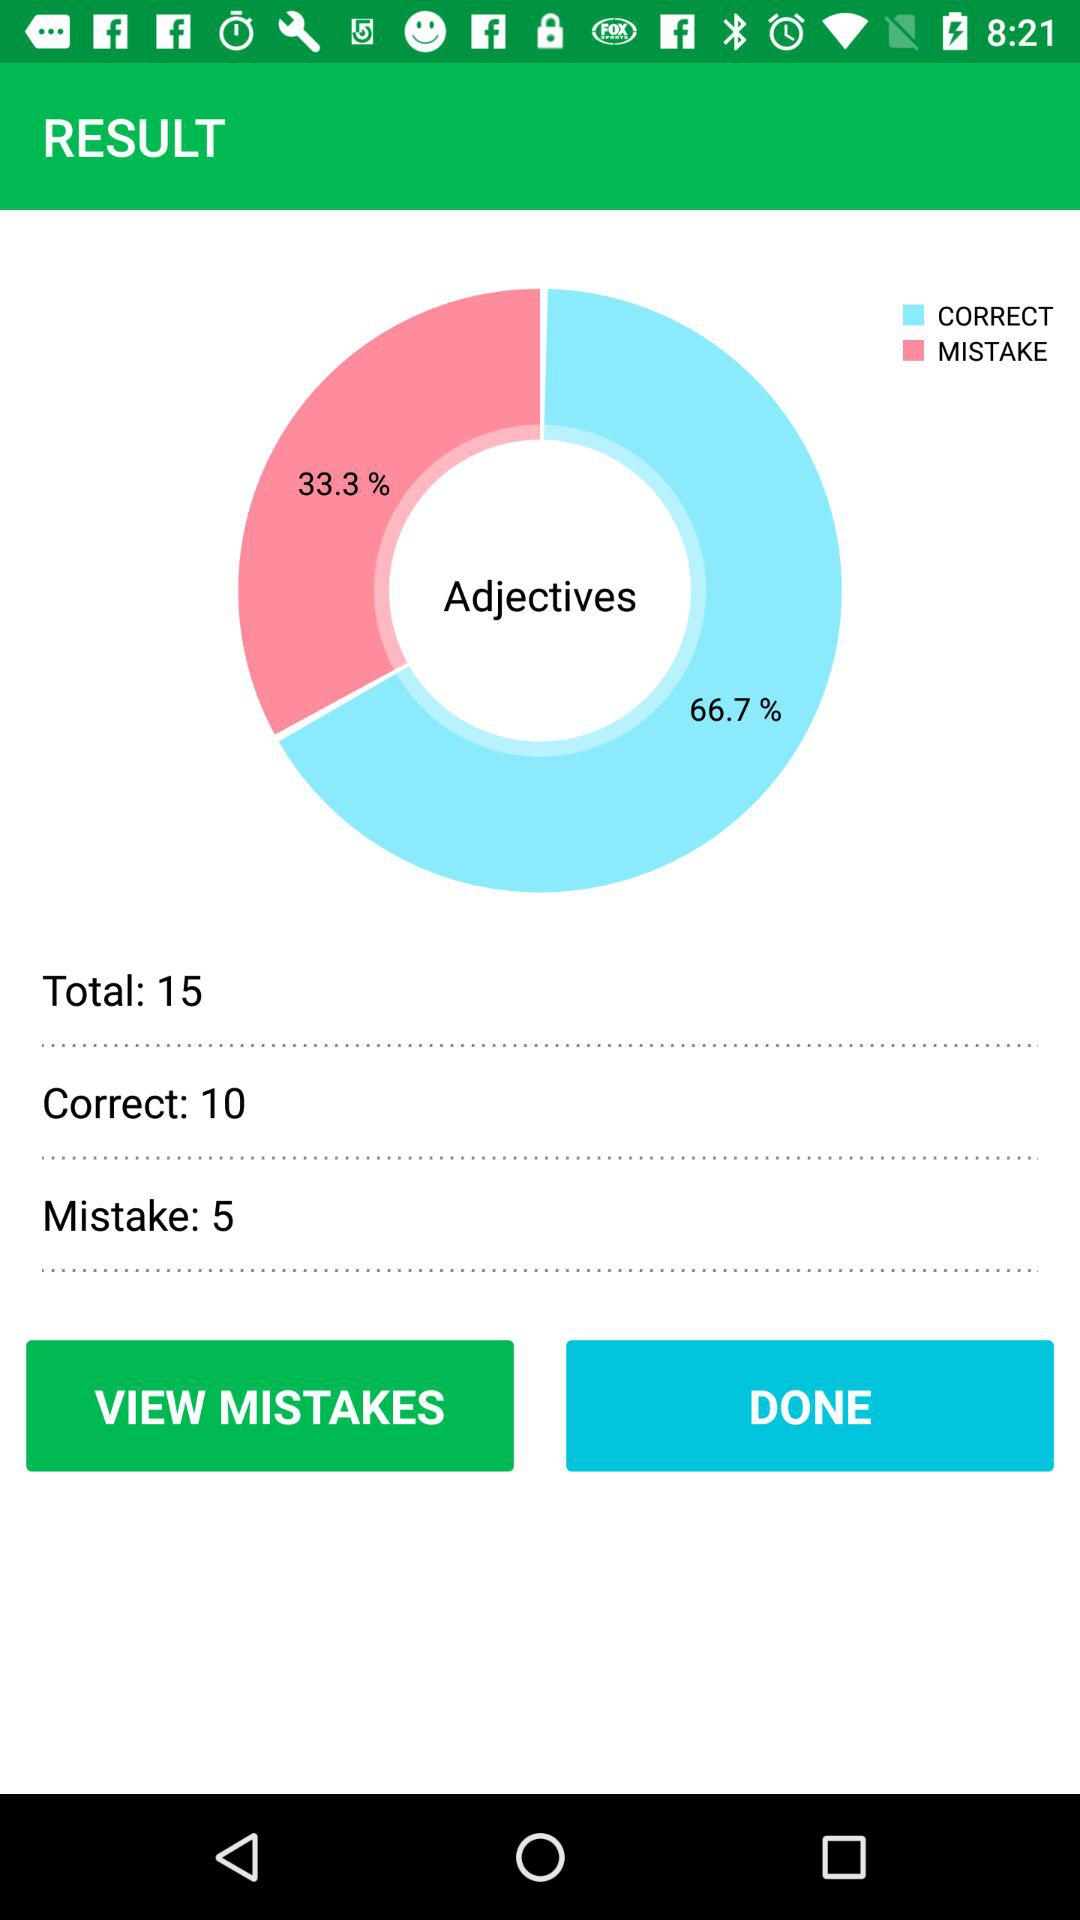What percentage of the answers are correct?
Answer the question using a single word or phrase. 66.7% 